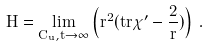Convert formula to latex. <formula><loc_0><loc_0><loc_500><loc_500>H = \lim _ { C _ { u } , t \rightarrow \infty } \left ( r ^ { 2 } ( t r \chi ^ { \prime } - \frac { 2 } { r } ) \right ) \, .</formula> 